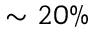<formula> <loc_0><loc_0><loc_500><loc_500>\sim 2 0 \%</formula> 